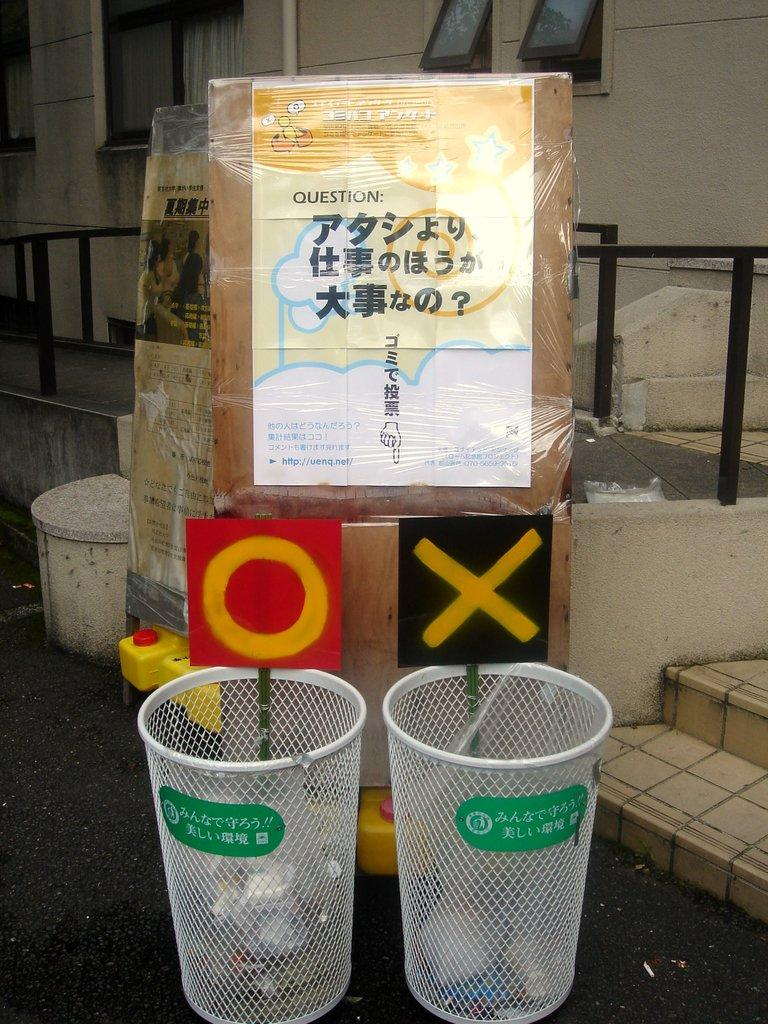Provide a one-sentence caption for the provided image. two basket cans that have an o above one and an x above the other. 